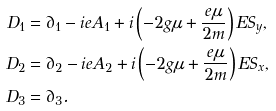<formula> <loc_0><loc_0><loc_500><loc_500>D _ { 1 } & = \partial _ { 1 } - i e A _ { 1 } + i \left ( - 2 g \mu + \frac { e \mu } { 2 m } \right ) E S _ { y } , \\ D _ { 2 } & = \partial _ { 2 } - i e A _ { 2 } + i \left ( - 2 g \mu + \frac { e \mu } { 2 m } \right ) E S _ { x } , \\ D _ { 3 } & = \partial _ { 3 } .</formula> 